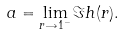Convert formula to latex. <formula><loc_0><loc_0><loc_500><loc_500>a = \lim _ { r \rightarrow 1 ^ { - } } \Im h ( r ) .</formula> 